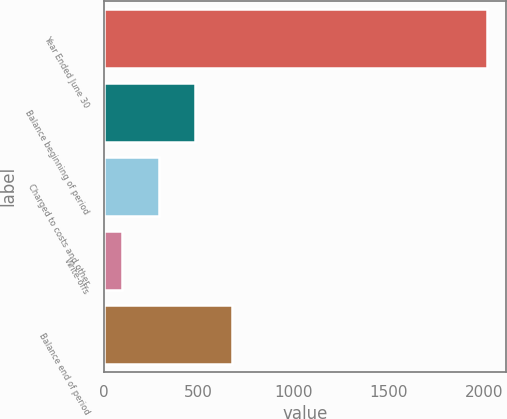Convert chart. <chart><loc_0><loc_0><loc_500><loc_500><bar_chart><fcel>Year Ended June 30<fcel>Balance beginning of period<fcel>Charged to costs and other<fcel>Write-offs<fcel>Balance end of period<nl><fcel>2018<fcel>482<fcel>290<fcel>98<fcel>674<nl></chart> 